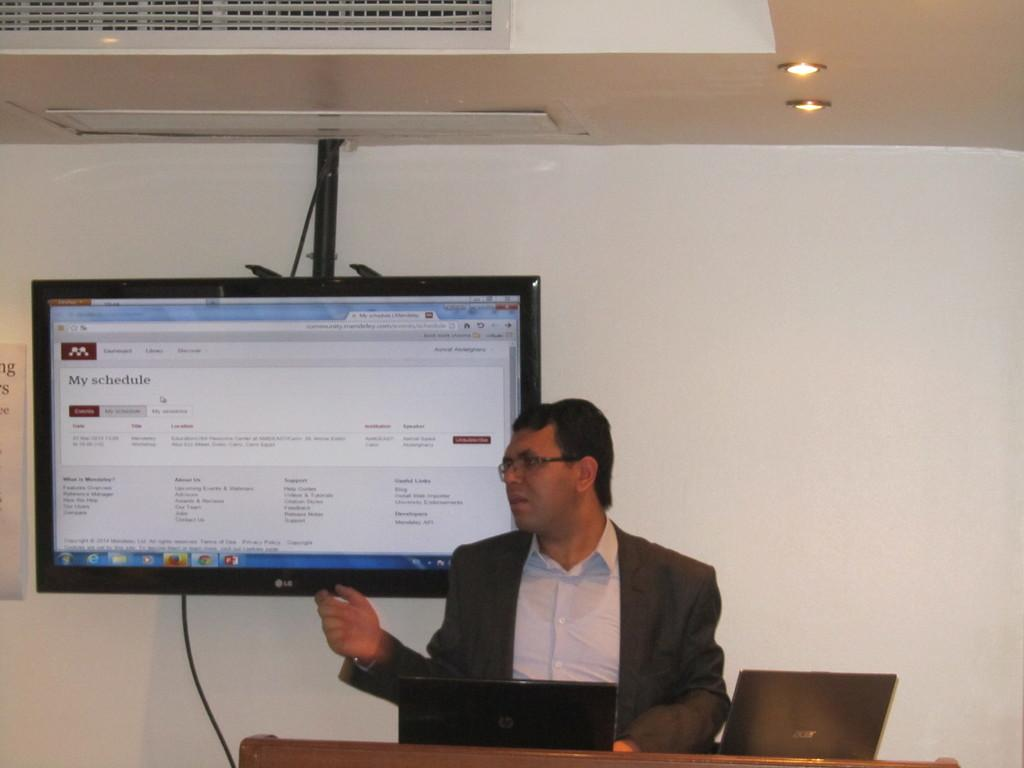<image>
Describe the image concisely. A man gives a talk in front of a screen which says My Schedule. 